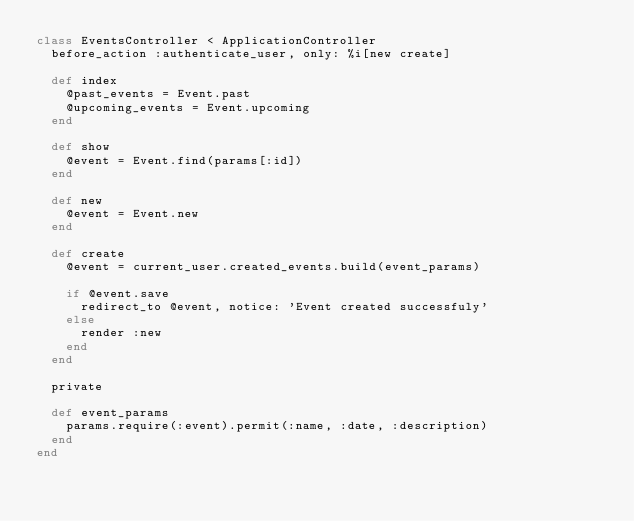Convert code to text. <code><loc_0><loc_0><loc_500><loc_500><_Ruby_>class EventsController < ApplicationController
  before_action :authenticate_user, only: %i[new create]

  def index
    @past_events = Event.past
    @upcoming_events = Event.upcoming
  end

  def show
    @event = Event.find(params[:id])
  end

  def new
    @event = Event.new
  end

  def create
    @event = current_user.created_events.build(event_params)

    if @event.save
      redirect_to @event, notice: 'Event created successfuly'
    else
      render :new
    end
  end

  private

  def event_params
    params.require(:event).permit(:name, :date, :description)
  end
end
</code> 